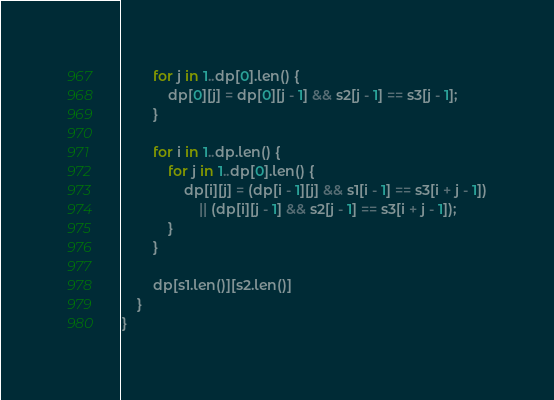<code> <loc_0><loc_0><loc_500><loc_500><_Rust_>
        for j in 1..dp[0].len() {
            dp[0][j] = dp[0][j - 1] && s2[j - 1] == s3[j - 1];
        }

        for i in 1..dp.len() {
            for j in 1..dp[0].len() {
                dp[i][j] = (dp[i - 1][j] && s1[i - 1] == s3[i + j - 1])
                    || (dp[i][j - 1] && s2[j - 1] == s3[i + j - 1]);
            }
        }

        dp[s1.len()][s2.len()]
    }
}
</code> 